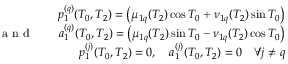Convert formula to latex. <formula><loc_0><loc_0><loc_500><loc_500>\begin{array} { r l r } & { p _ { 1 } ^ { ( q ) } ( T _ { 0 } , T _ { 2 } ) = \left ( \mu _ { 1 q } ( T _ { 2 } ) \cos T _ { 0 } + \nu _ { 1 q } ( T _ { 2 } ) \sin T _ { 0 } \right ) } \\ { a n d } & { a _ { 1 } ^ { ( q ) } ( T _ { 0 } , T _ { 2 } ) = \left ( \mu _ { 1 q } ( T _ { 2 } ) \sin T _ { 0 } - \nu _ { 1 q } ( T _ { 2 } ) \cos T _ { 0 } \right ) } \\ & { p _ { 1 } ^ { ( j ) } ( T _ { 0 } , T _ { 2 } ) = 0 , \quad a _ { 1 } ^ { ( j ) } ( T _ { 0 } , T _ { 2 } ) = 0 \quad \forall j \neq q } \end{array}</formula> 